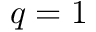Convert formula to latex. <formula><loc_0><loc_0><loc_500><loc_500>q = 1</formula> 